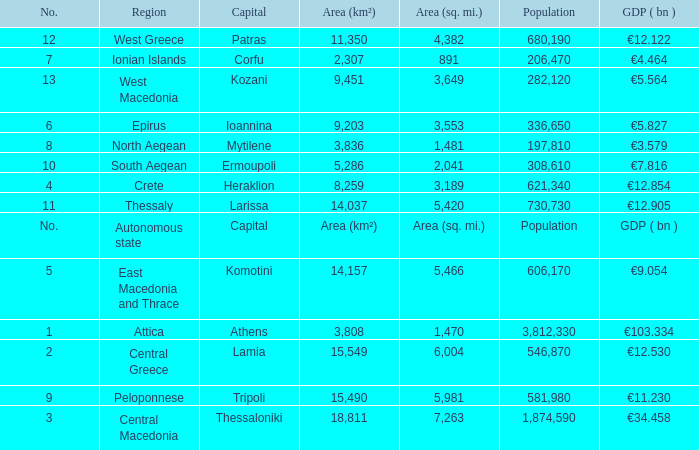What is the population where the area (sq. mi.) is area (sq. mi.)? Population. 